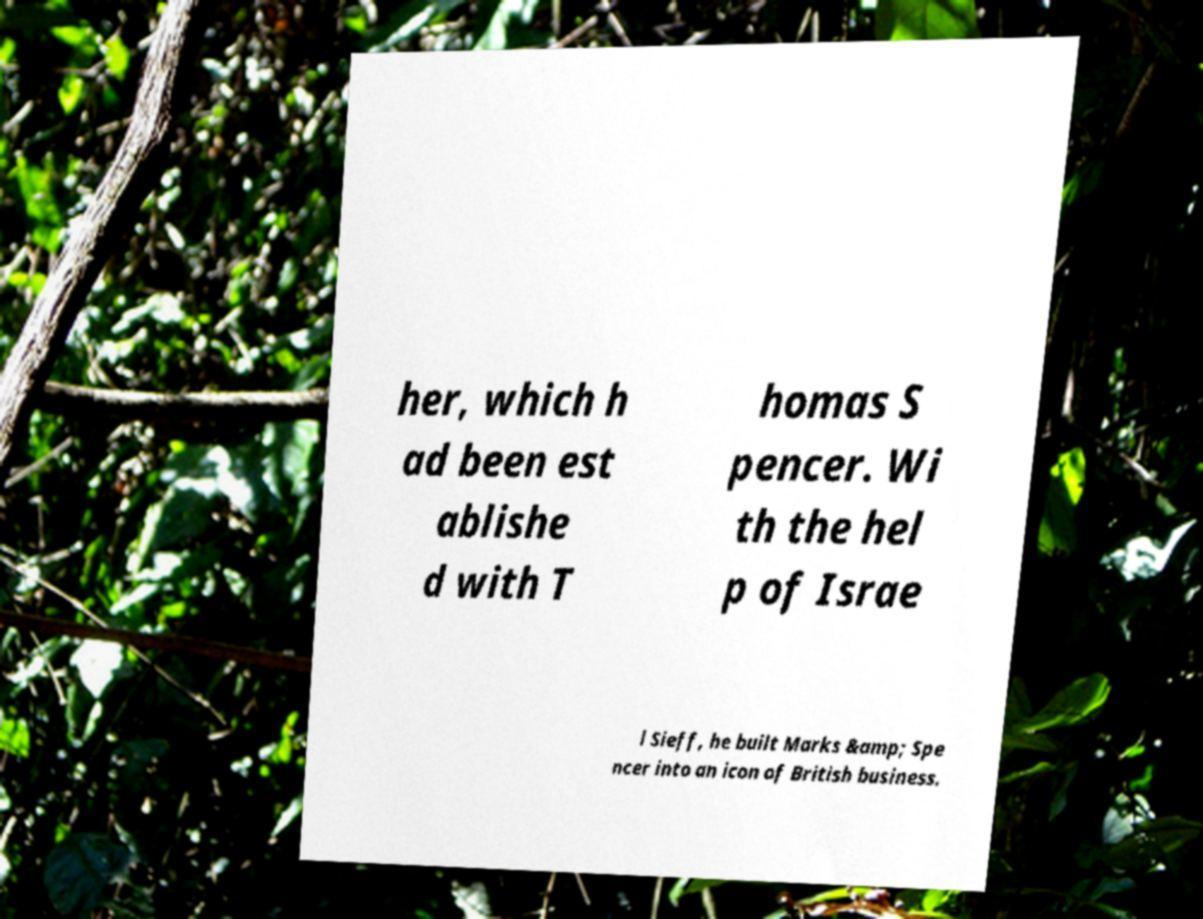Please read and relay the text visible in this image. What does it say? her, which h ad been est ablishe d with T homas S pencer. Wi th the hel p of Israe l Sieff, he built Marks &amp; Spe ncer into an icon of British business. 